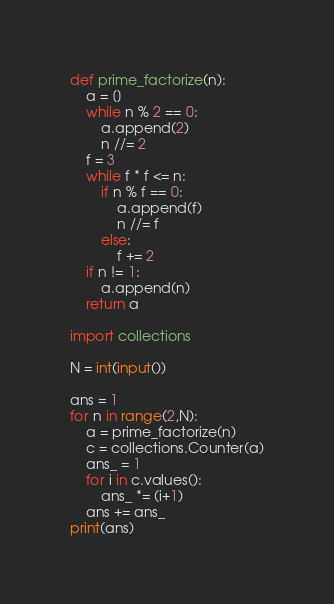Convert code to text. <code><loc_0><loc_0><loc_500><loc_500><_Python_>def prime_factorize(n):
    a = []
    while n % 2 == 0:
        a.append(2)
        n //= 2
    f = 3
    while f * f <= n:
        if n % f == 0:
            a.append(f)
            n //= f
        else:
            f += 2
    if n != 1:
        a.append(n)
    return a

import collections

N = int(input())

ans = 1
for n in range(2,N):
    a = prime_factorize(n)
    c = collections.Counter(a)
    ans_ = 1
    for i in c.values():
        ans_ *= (i+1)
    ans += ans_
print(ans)</code> 